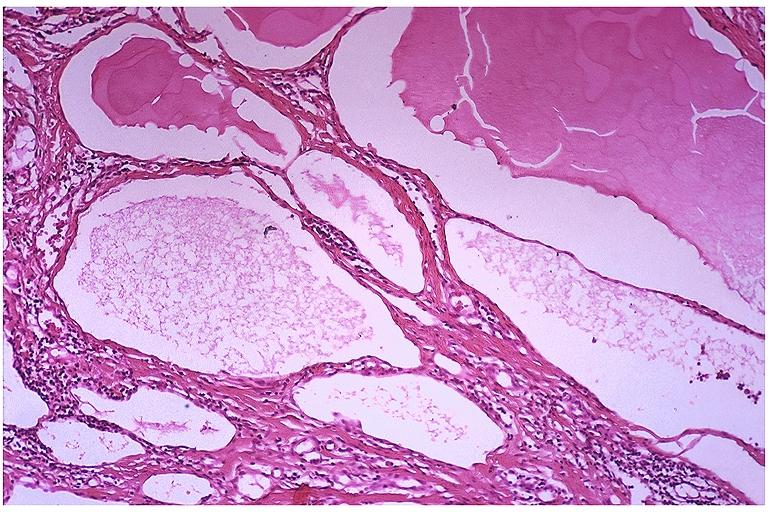s oral present?
Answer the question using a single word or phrase. Yes 